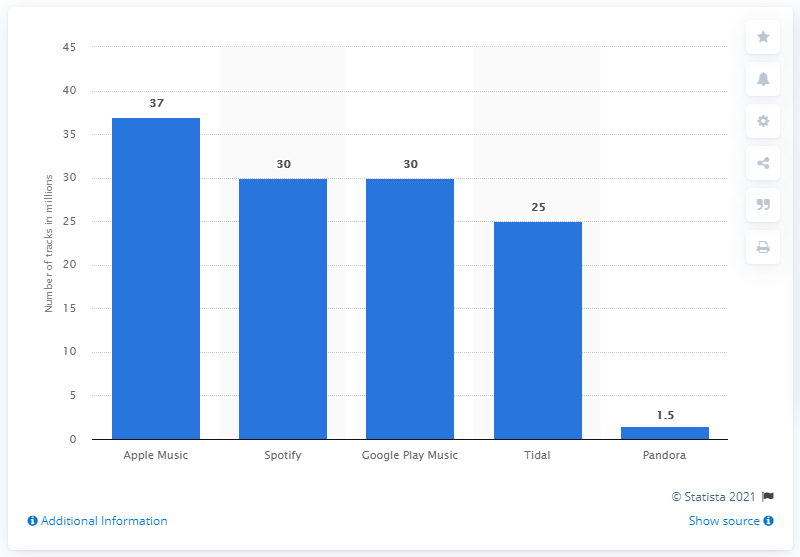Identify some key points in this picture. As of June 2015, Pandora had approximately 1.5 songs available for streaming. As of June 2015, Apple Music had offered 37 million songs to its customers. 